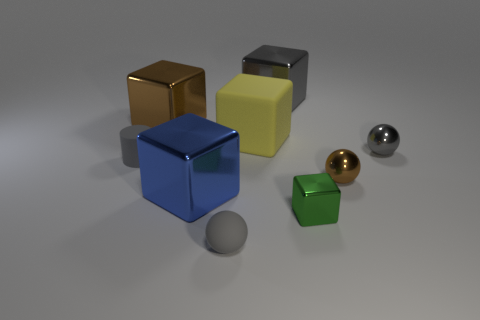Subtract all metal cubes. How many cubes are left? 1 Subtract all cyan cylinders. How many gray spheres are left? 2 Subtract all blue blocks. How many blocks are left? 4 Subtract 1 balls. How many balls are left? 2 Add 1 big yellow matte cubes. How many objects exist? 10 Subtract all cylinders. How many objects are left? 8 Subtract all gray blocks. Subtract all blue cylinders. How many blocks are left? 4 Subtract all small green shiny objects. Subtract all matte cylinders. How many objects are left? 7 Add 7 tiny blocks. How many tiny blocks are left? 8 Add 8 tiny red rubber cubes. How many tiny red rubber cubes exist? 8 